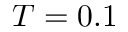Convert formula to latex. <formula><loc_0><loc_0><loc_500><loc_500>T = 0 . 1</formula> 